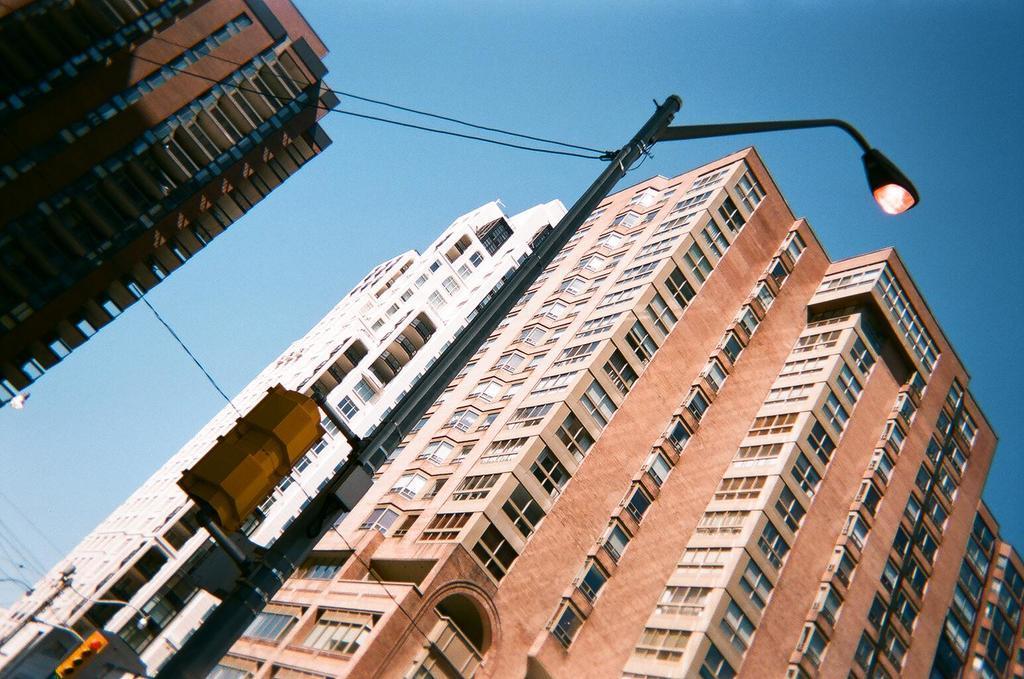In one or two sentences, can you explain what this image depicts? In this image, we can see buildings and there are poles along with wires and we can see lights. At the top, there is sky. 